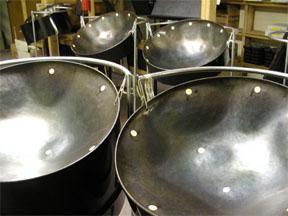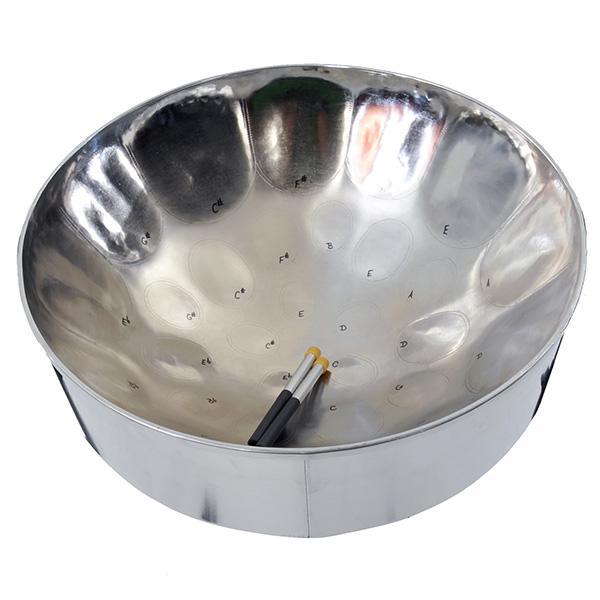The first image is the image on the left, the second image is the image on the right. For the images displayed, is the sentence "The right image shows the interior of a concave metal drum, with a pair of drumsticks in its bowl." factually correct? Answer yes or no. Yes. The first image is the image on the left, the second image is the image on the right. Analyze the images presented: Is the assertion "There are two drum stick laying in the middle of an inverted metal drum." valid? Answer yes or no. Yes. 